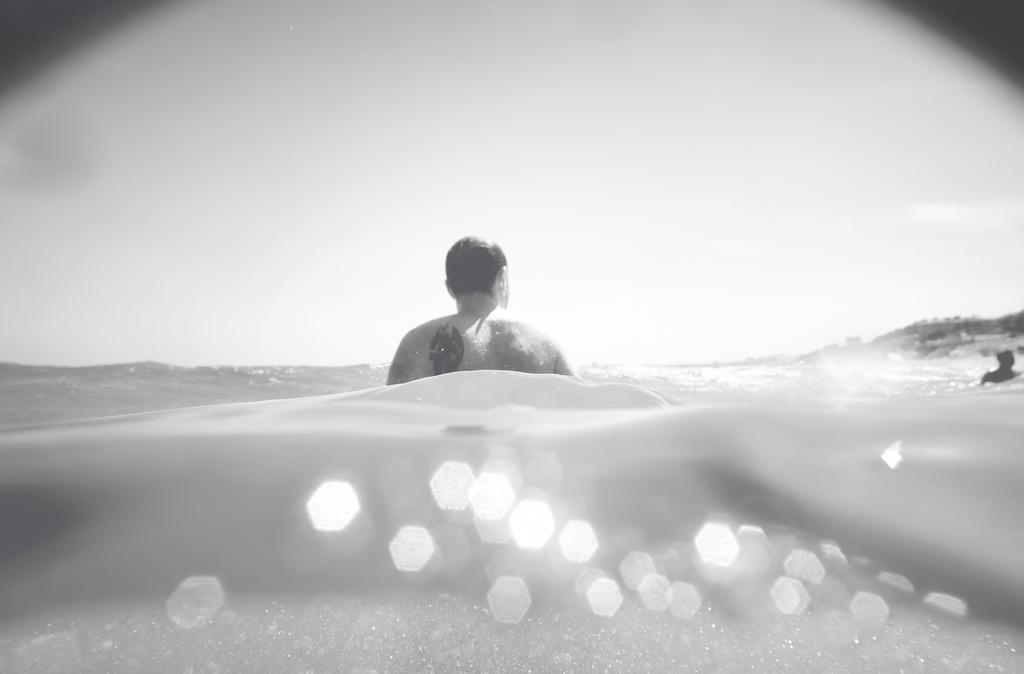What are the persons in the image doing? The persons in the image are in the water. Can you describe the setting of the image? The persons are in the water, which suggests a swimming or beach environment. What type of dogs can be seen playing with the texture of the water in the image? There are no dogs present in the image, and the water does not have a texture that can be played with. 